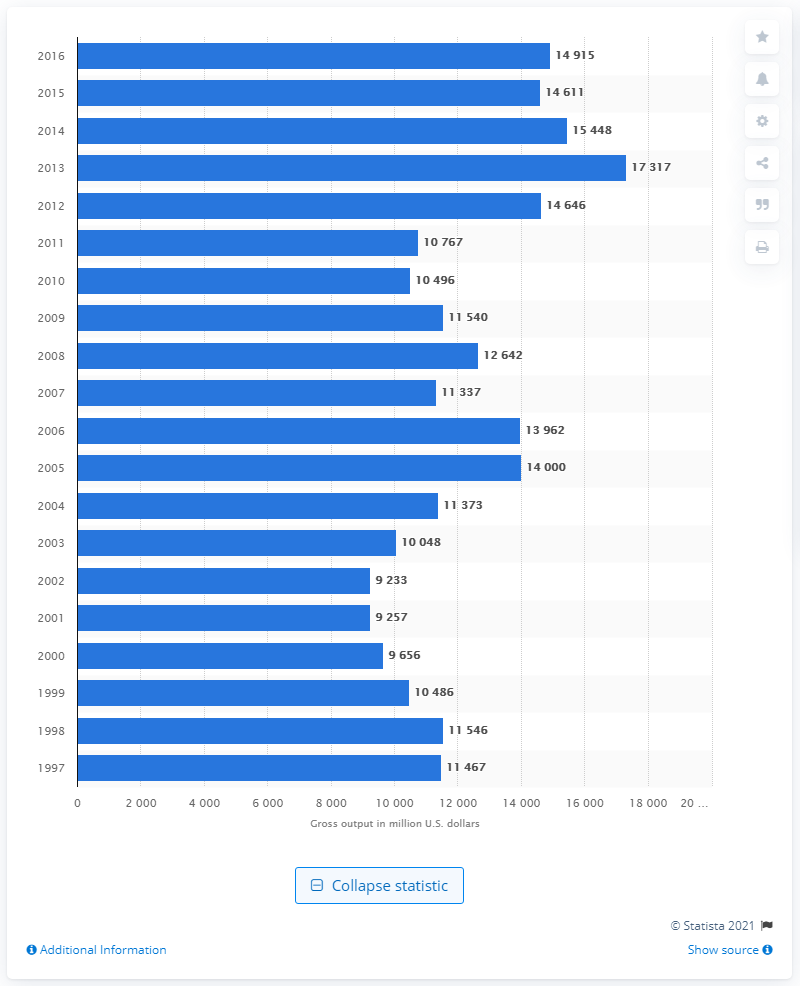Point out several critical features in this image. The gross output of pesticide and other agricultural chemical manufacturing in the United States in 2016 was approximately 14,915. In 1998, the gross output of pesticide and other agricultural chemical manufacturing was 11,540. 